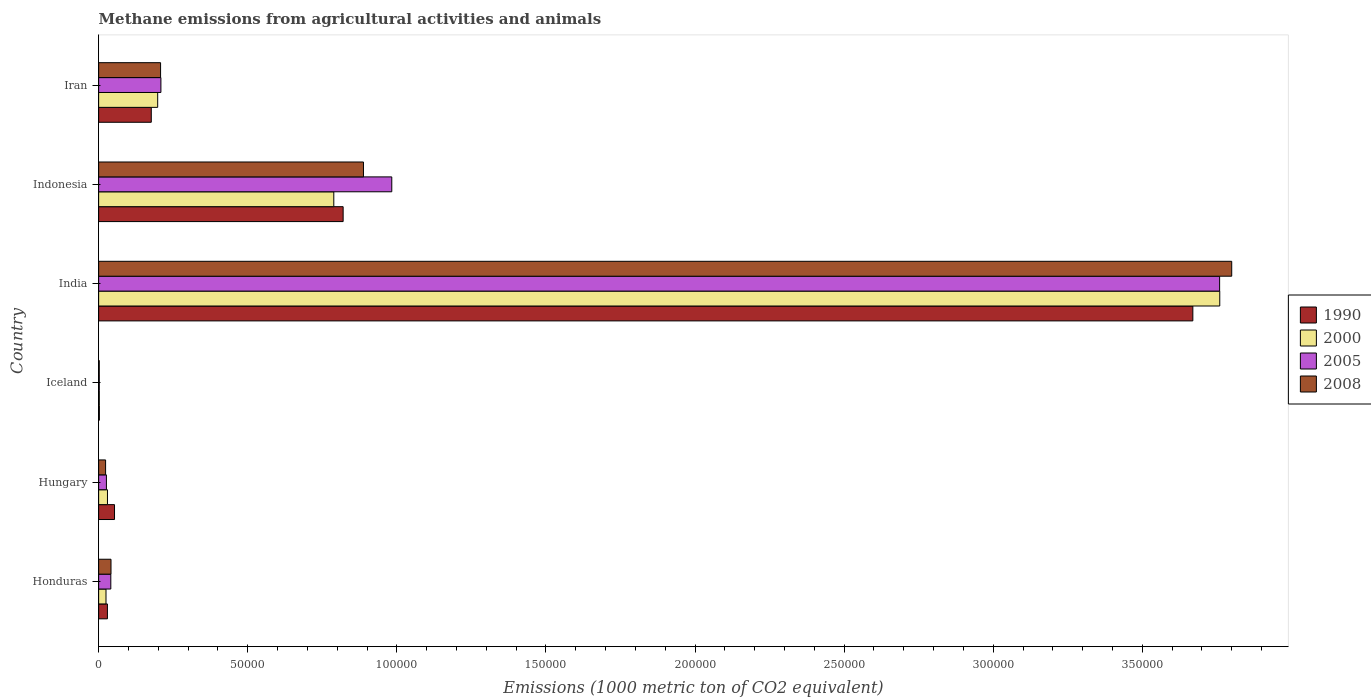How many groups of bars are there?
Provide a short and direct response. 6. How many bars are there on the 2nd tick from the top?
Make the answer very short. 4. How many bars are there on the 4th tick from the bottom?
Make the answer very short. 4. What is the label of the 2nd group of bars from the top?
Provide a short and direct response. Indonesia. In how many cases, is the number of bars for a given country not equal to the number of legend labels?
Give a very brief answer. 0. What is the amount of methane emitted in 2000 in Hungary?
Offer a very short reply. 2961.9. Across all countries, what is the maximum amount of methane emitted in 2008?
Offer a terse response. 3.80e+05. Across all countries, what is the minimum amount of methane emitted in 1990?
Give a very brief answer. 245.3. What is the total amount of methane emitted in 2008 in the graph?
Your answer should be compact. 4.96e+05. What is the difference between the amount of methane emitted in 2000 in Iceland and that in Indonesia?
Offer a terse response. -7.86e+04. What is the difference between the amount of methane emitted in 2008 in Honduras and the amount of methane emitted in 2000 in Iran?
Provide a succinct answer. -1.57e+04. What is the average amount of methane emitted in 2005 per country?
Your answer should be very brief. 8.37e+04. What is the difference between the amount of methane emitted in 2008 and amount of methane emitted in 1990 in Honduras?
Offer a terse response. 1202.8. What is the ratio of the amount of methane emitted in 1990 in Indonesia to that in Iran?
Your answer should be very brief. 4.64. Is the difference between the amount of methane emitted in 2008 in Honduras and India greater than the difference between the amount of methane emitted in 1990 in Honduras and India?
Your answer should be compact. No. What is the difference between the highest and the second highest amount of methane emitted in 2008?
Offer a terse response. 2.91e+05. What is the difference between the highest and the lowest amount of methane emitted in 2008?
Give a very brief answer. 3.80e+05. In how many countries, is the amount of methane emitted in 1990 greater than the average amount of methane emitted in 1990 taken over all countries?
Your response must be concise. 2. Is the sum of the amount of methane emitted in 1990 in Iceland and India greater than the maximum amount of methane emitted in 2000 across all countries?
Keep it short and to the point. No. What does the 4th bar from the top in Iceland represents?
Offer a terse response. 1990. What does the 1st bar from the bottom in Iran represents?
Ensure brevity in your answer.  1990. Is it the case that in every country, the sum of the amount of methane emitted in 2005 and amount of methane emitted in 2008 is greater than the amount of methane emitted in 1990?
Provide a succinct answer. No. How many countries are there in the graph?
Provide a short and direct response. 6. Are the values on the major ticks of X-axis written in scientific E-notation?
Give a very brief answer. No. How are the legend labels stacked?
Your answer should be compact. Vertical. What is the title of the graph?
Your response must be concise. Methane emissions from agricultural activities and animals. What is the label or title of the X-axis?
Offer a terse response. Emissions (1000 metric ton of CO2 equivalent). What is the Emissions (1000 metric ton of CO2 equivalent) in 1990 in Honduras?
Your answer should be very brief. 2946.5. What is the Emissions (1000 metric ton of CO2 equivalent) in 2000 in Honduras?
Give a very brief answer. 2470.9. What is the Emissions (1000 metric ton of CO2 equivalent) of 2005 in Honduras?
Your response must be concise. 4084.8. What is the Emissions (1000 metric ton of CO2 equivalent) in 2008 in Honduras?
Your response must be concise. 4149.3. What is the Emissions (1000 metric ton of CO2 equivalent) of 1990 in Hungary?
Offer a very short reply. 5327.6. What is the Emissions (1000 metric ton of CO2 equivalent) of 2000 in Hungary?
Your answer should be very brief. 2961.9. What is the Emissions (1000 metric ton of CO2 equivalent) in 2005 in Hungary?
Your answer should be very brief. 2613. What is the Emissions (1000 metric ton of CO2 equivalent) of 2008 in Hungary?
Ensure brevity in your answer.  2335.2. What is the Emissions (1000 metric ton of CO2 equivalent) of 1990 in Iceland?
Make the answer very short. 245.3. What is the Emissions (1000 metric ton of CO2 equivalent) in 2000 in Iceland?
Provide a short and direct response. 223.7. What is the Emissions (1000 metric ton of CO2 equivalent) of 2005 in Iceland?
Give a very brief answer. 214.9. What is the Emissions (1000 metric ton of CO2 equivalent) of 2008 in Iceland?
Your answer should be very brief. 209.2. What is the Emissions (1000 metric ton of CO2 equivalent) in 1990 in India?
Your answer should be compact. 3.67e+05. What is the Emissions (1000 metric ton of CO2 equivalent) in 2000 in India?
Ensure brevity in your answer.  3.76e+05. What is the Emissions (1000 metric ton of CO2 equivalent) in 2005 in India?
Make the answer very short. 3.76e+05. What is the Emissions (1000 metric ton of CO2 equivalent) in 2008 in India?
Keep it short and to the point. 3.80e+05. What is the Emissions (1000 metric ton of CO2 equivalent) in 1990 in Indonesia?
Give a very brief answer. 8.20e+04. What is the Emissions (1000 metric ton of CO2 equivalent) in 2000 in Indonesia?
Provide a short and direct response. 7.89e+04. What is the Emissions (1000 metric ton of CO2 equivalent) in 2005 in Indonesia?
Provide a succinct answer. 9.83e+04. What is the Emissions (1000 metric ton of CO2 equivalent) in 2008 in Indonesia?
Your answer should be very brief. 8.88e+04. What is the Emissions (1000 metric ton of CO2 equivalent) in 1990 in Iran?
Offer a terse response. 1.77e+04. What is the Emissions (1000 metric ton of CO2 equivalent) of 2000 in Iran?
Give a very brief answer. 1.98e+04. What is the Emissions (1000 metric ton of CO2 equivalent) in 2005 in Iran?
Offer a terse response. 2.09e+04. What is the Emissions (1000 metric ton of CO2 equivalent) of 2008 in Iran?
Your answer should be very brief. 2.08e+04. Across all countries, what is the maximum Emissions (1000 metric ton of CO2 equivalent) of 1990?
Provide a succinct answer. 3.67e+05. Across all countries, what is the maximum Emissions (1000 metric ton of CO2 equivalent) in 2000?
Provide a succinct answer. 3.76e+05. Across all countries, what is the maximum Emissions (1000 metric ton of CO2 equivalent) in 2005?
Provide a short and direct response. 3.76e+05. Across all countries, what is the maximum Emissions (1000 metric ton of CO2 equivalent) in 2008?
Give a very brief answer. 3.80e+05. Across all countries, what is the minimum Emissions (1000 metric ton of CO2 equivalent) in 1990?
Your answer should be very brief. 245.3. Across all countries, what is the minimum Emissions (1000 metric ton of CO2 equivalent) in 2000?
Provide a short and direct response. 223.7. Across all countries, what is the minimum Emissions (1000 metric ton of CO2 equivalent) in 2005?
Offer a very short reply. 214.9. Across all countries, what is the minimum Emissions (1000 metric ton of CO2 equivalent) of 2008?
Your response must be concise. 209.2. What is the total Emissions (1000 metric ton of CO2 equivalent) in 1990 in the graph?
Ensure brevity in your answer.  4.75e+05. What is the total Emissions (1000 metric ton of CO2 equivalent) of 2000 in the graph?
Ensure brevity in your answer.  4.80e+05. What is the total Emissions (1000 metric ton of CO2 equivalent) of 2005 in the graph?
Make the answer very short. 5.02e+05. What is the total Emissions (1000 metric ton of CO2 equivalent) in 2008 in the graph?
Make the answer very short. 4.96e+05. What is the difference between the Emissions (1000 metric ton of CO2 equivalent) of 1990 in Honduras and that in Hungary?
Provide a short and direct response. -2381.1. What is the difference between the Emissions (1000 metric ton of CO2 equivalent) in 2000 in Honduras and that in Hungary?
Your answer should be compact. -491. What is the difference between the Emissions (1000 metric ton of CO2 equivalent) of 2005 in Honduras and that in Hungary?
Ensure brevity in your answer.  1471.8. What is the difference between the Emissions (1000 metric ton of CO2 equivalent) in 2008 in Honduras and that in Hungary?
Offer a very short reply. 1814.1. What is the difference between the Emissions (1000 metric ton of CO2 equivalent) of 1990 in Honduras and that in Iceland?
Make the answer very short. 2701.2. What is the difference between the Emissions (1000 metric ton of CO2 equivalent) of 2000 in Honduras and that in Iceland?
Provide a succinct answer. 2247.2. What is the difference between the Emissions (1000 metric ton of CO2 equivalent) in 2005 in Honduras and that in Iceland?
Offer a terse response. 3869.9. What is the difference between the Emissions (1000 metric ton of CO2 equivalent) in 2008 in Honduras and that in Iceland?
Your answer should be very brief. 3940.1. What is the difference between the Emissions (1000 metric ton of CO2 equivalent) in 1990 in Honduras and that in India?
Offer a terse response. -3.64e+05. What is the difference between the Emissions (1000 metric ton of CO2 equivalent) in 2000 in Honduras and that in India?
Your answer should be compact. -3.74e+05. What is the difference between the Emissions (1000 metric ton of CO2 equivalent) in 2005 in Honduras and that in India?
Your answer should be very brief. -3.72e+05. What is the difference between the Emissions (1000 metric ton of CO2 equivalent) in 2008 in Honduras and that in India?
Your answer should be compact. -3.76e+05. What is the difference between the Emissions (1000 metric ton of CO2 equivalent) of 1990 in Honduras and that in Indonesia?
Offer a very short reply. -7.91e+04. What is the difference between the Emissions (1000 metric ton of CO2 equivalent) in 2000 in Honduras and that in Indonesia?
Your answer should be compact. -7.64e+04. What is the difference between the Emissions (1000 metric ton of CO2 equivalent) in 2005 in Honduras and that in Indonesia?
Your response must be concise. -9.42e+04. What is the difference between the Emissions (1000 metric ton of CO2 equivalent) of 2008 in Honduras and that in Indonesia?
Your answer should be compact. -8.47e+04. What is the difference between the Emissions (1000 metric ton of CO2 equivalent) of 1990 in Honduras and that in Iran?
Your answer should be very brief. -1.47e+04. What is the difference between the Emissions (1000 metric ton of CO2 equivalent) of 2000 in Honduras and that in Iran?
Your answer should be very brief. -1.73e+04. What is the difference between the Emissions (1000 metric ton of CO2 equivalent) of 2005 in Honduras and that in Iran?
Your answer should be very brief. -1.68e+04. What is the difference between the Emissions (1000 metric ton of CO2 equivalent) of 2008 in Honduras and that in Iran?
Provide a succinct answer. -1.66e+04. What is the difference between the Emissions (1000 metric ton of CO2 equivalent) in 1990 in Hungary and that in Iceland?
Ensure brevity in your answer.  5082.3. What is the difference between the Emissions (1000 metric ton of CO2 equivalent) in 2000 in Hungary and that in Iceland?
Make the answer very short. 2738.2. What is the difference between the Emissions (1000 metric ton of CO2 equivalent) of 2005 in Hungary and that in Iceland?
Offer a very short reply. 2398.1. What is the difference between the Emissions (1000 metric ton of CO2 equivalent) of 2008 in Hungary and that in Iceland?
Offer a terse response. 2126. What is the difference between the Emissions (1000 metric ton of CO2 equivalent) in 1990 in Hungary and that in India?
Your answer should be very brief. -3.62e+05. What is the difference between the Emissions (1000 metric ton of CO2 equivalent) of 2000 in Hungary and that in India?
Offer a very short reply. -3.73e+05. What is the difference between the Emissions (1000 metric ton of CO2 equivalent) of 2005 in Hungary and that in India?
Offer a very short reply. -3.73e+05. What is the difference between the Emissions (1000 metric ton of CO2 equivalent) in 2008 in Hungary and that in India?
Provide a succinct answer. -3.78e+05. What is the difference between the Emissions (1000 metric ton of CO2 equivalent) in 1990 in Hungary and that in Indonesia?
Your response must be concise. -7.67e+04. What is the difference between the Emissions (1000 metric ton of CO2 equivalent) in 2000 in Hungary and that in Indonesia?
Provide a short and direct response. -7.59e+04. What is the difference between the Emissions (1000 metric ton of CO2 equivalent) of 2005 in Hungary and that in Indonesia?
Make the answer very short. -9.57e+04. What is the difference between the Emissions (1000 metric ton of CO2 equivalent) of 2008 in Hungary and that in Indonesia?
Ensure brevity in your answer.  -8.65e+04. What is the difference between the Emissions (1000 metric ton of CO2 equivalent) of 1990 in Hungary and that in Iran?
Offer a very short reply. -1.23e+04. What is the difference between the Emissions (1000 metric ton of CO2 equivalent) of 2000 in Hungary and that in Iran?
Provide a short and direct response. -1.68e+04. What is the difference between the Emissions (1000 metric ton of CO2 equivalent) in 2005 in Hungary and that in Iran?
Your answer should be very brief. -1.83e+04. What is the difference between the Emissions (1000 metric ton of CO2 equivalent) in 2008 in Hungary and that in Iran?
Your response must be concise. -1.84e+04. What is the difference between the Emissions (1000 metric ton of CO2 equivalent) in 1990 in Iceland and that in India?
Ensure brevity in your answer.  -3.67e+05. What is the difference between the Emissions (1000 metric ton of CO2 equivalent) of 2000 in Iceland and that in India?
Your answer should be very brief. -3.76e+05. What is the difference between the Emissions (1000 metric ton of CO2 equivalent) of 2005 in Iceland and that in India?
Give a very brief answer. -3.76e+05. What is the difference between the Emissions (1000 metric ton of CO2 equivalent) of 2008 in Iceland and that in India?
Offer a very short reply. -3.80e+05. What is the difference between the Emissions (1000 metric ton of CO2 equivalent) in 1990 in Iceland and that in Indonesia?
Keep it short and to the point. -8.18e+04. What is the difference between the Emissions (1000 metric ton of CO2 equivalent) of 2000 in Iceland and that in Indonesia?
Ensure brevity in your answer.  -7.86e+04. What is the difference between the Emissions (1000 metric ton of CO2 equivalent) in 2005 in Iceland and that in Indonesia?
Give a very brief answer. -9.81e+04. What is the difference between the Emissions (1000 metric ton of CO2 equivalent) in 2008 in Iceland and that in Indonesia?
Your response must be concise. -8.86e+04. What is the difference between the Emissions (1000 metric ton of CO2 equivalent) in 1990 in Iceland and that in Iran?
Ensure brevity in your answer.  -1.74e+04. What is the difference between the Emissions (1000 metric ton of CO2 equivalent) of 2000 in Iceland and that in Iran?
Your answer should be compact. -1.96e+04. What is the difference between the Emissions (1000 metric ton of CO2 equivalent) in 2005 in Iceland and that in Iran?
Your answer should be compact. -2.07e+04. What is the difference between the Emissions (1000 metric ton of CO2 equivalent) in 2008 in Iceland and that in Iran?
Ensure brevity in your answer.  -2.06e+04. What is the difference between the Emissions (1000 metric ton of CO2 equivalent) of 1990 in India and that in Indonesia?
Give a very brief answer. 2.85e+05. What is the difference between the Emissions (1000 metric ton of CO2 equivalent) in 2000 in India and that in Indonesia?
Provide a succinct answer. 2.97e+05. What is the difference between the Emissions (1000 metric ton of CO2 equivalent) of 2005 in India and that in Indonesia?
Provide a succinct answer. 2.78e+05. What is the difference between the Emissions (1000 metric ton of CO2 equivalent) in 2008 in India and that in Indonesia?
Offer a very short reply. 2.91e+05. What is the difference between the Emissions (1000 metric ton of CO2 equivalent) of 1990 in India and that in Iran?
Ensure brevity in your answer.  3.49e+05. What is the difference between the Emissions (1000 metric ton of CO2 equivalent) in 2000 in India and that in Iran?
Your answer should be very brief. 3.56e+05. What is the difference between the Emissions (1000 metric ton of CO2 equivalent) of 2005 in India and that in Iran?
Keep it short and to the point. 3.55e+05. What is the difference between the Emissions (1000 metric ton of CO2 equivalent) in 2008 in India and that in Iran?
Offer a very short reply. 3.59e+05. What is the difference between the Emissions (1000 metric ton of CO2 equivalent) of 1990 in Indonesia and that in Iran?
Your answer should be very brief. 6.43e+04. What is the difference between the Emissions (1000 metric ton of CO2 equivalent) in 2000 in Indonesia and that in Iran?
Give a very brief answer. 5.91e+04. What is the difference between the Emissions (1000 metric ton of CO2 equivalent) in 2005 in Indonesia and that in Iran?
Give a very brief answer. 7.74e+04. What is the difference between the Emissions (1000 metric ton of CO2 equivalent) in 2008 in Indonesia and that in Iran?
Make the answer very short. 6.80e+04. What is the difference between the Emissions (1000 metric ton of CO2 equivalent) of 1990 in Honduras and the Emissions (1000 metric ton of CO2 equivalent) of 2000 in Hungary?
Provide a succinct answer. -15.4. What is the difference between the Emissions (1000 metric ton of CO2 equivalent) in 1990 in Honduras and the Emissions (1000 metric ton of CO2 equivalent) in 2005 in Hungary?
Give a very brief answer. 333.5. What is the difference between the Emissions (1000 metric ton of CO2 equivalent) in 1990 in Honduras and the Emissions (1000 metric ton of CO2 equivalent) in 2008 in Hungary?
Offer a terse response. 611.3. What is the difference between the Emissions (1000 metric ton of CO2 equivalent) in 2000 in Honduras and the Emissions (1000 metric ton of CO2 equivalent) in 2005 in Hungary?
Give a very brief answer. -142.1. What is the difference between the Emissions (1000 metric ton of CO2 equivalent) of 2000 in Honduras and the Emissions (1000 metric ton of CO2 equivalent) of 2008 in Hungary?
Provide a short and direct response. 135.7. What is the difference between the Emissions (1000 metric ton of CO2 equivalent) of 2005 in Honduras and the Emissions (1000 metric ton of CO2 equivalent) of 2008 in Hungary?
Provide a short and direct response. 1749.6. What is the difference between the Emissions (1000 metric ton of CO2 equivalent) of 1990 in Honduras and the Emissions (1000 metric ton of CO2 equivalent) of 2000 in Iceland?
Offer a very short reply. 2722.8. What is the difference between the Emissions (1000 metric ton of CO2 equivalent) of 1990 in Honduras and the Emissions (1000 metric ton of CO2 equivalent) of 2005 in Iceland?
Provide a short and direct response. 2731.6. What is the difference between the Emissions (1000 metric ton of CO2 equivalent) of 1990 in Honduras and the Emissions (1000 metric ton of CO2 equivalent) of 2008 in Iceland?
Offer a terse response. 2737.3. What is the difference between the Emissions (1000 metric ton of CO2 equivalent) of 2000 in Honduras and the Emissions (1000 metric ton of CO2 equivalent) of 2005 in Iceland?
Keep it short and to the point. 2256. What is the difference between the Emissions (1000 metric ton of CO2 equivalent) of 2000 in Honduras and the Emissions (1000 metric ton of CO2 equivalent) of 2008 in Iceland?
Make the answer very short. 2261.7. What is the difference between the Emissions (1000 metric ton of CO2 equivalent) in 2005 in Honduras and the Emissions (1000 metric ton of CO2 equivalent) in 2008 in Iceland?
Your answer should be very brief. 3875.6. What is the difference between the Emissions (1000 metric ton of CO2 equivalent) in 1990 in Honduras and the Emissions (1000 metric ton of CO2 equivalent) in 2000 in India?
Your response must be concise. -3.73e+05. What is the difference between the Emissions (1000 metric ton of CO2 equivalent) in 1990 in Honduras and the Emissions (1000 metric ton of CO2 equivalent) in 2005 in India?
Offer a very short reply. -3.73e+05. What is the difference between the Emissions (1000 metric ton of CO2 equivalent) in 1990 in Honduras and the Emissions (1000 metric ton of CO2 equivalent) in 2008 in India?
Provide a succinct answer. -3.77e+05. What is the difference between the Emissions (1000 metric ton of CO2 equivalent) of 2000 in Honduras and the Emissions (1000 metric ton of CO2 equivalent) of 2005 in India?
Give a very brief answer. -3.73e+05. What is the difference between the Emissions (1000 metric ton of CO2 equivalent) in 2000 in Honduras and the Emissions (1000 metric ton of CO2 equivalent) in 2008 in India?
Your response must be concise. -3.78e+05. What is the difference between the Emissions (1000 metric ton of CO2 equivalent) in 2005 in Honduras and the Emissions (1000 metric ton of CO2 equivalent) in 2008 in India?
Give a very brief answer. -3.76e+05. What is the difference between the Emissions (1000 metric ton of CO2 equivalent) of 1990 in Honduras and the Emissions (1000 metric ton of CO2 equivalent) of 2000 in Indonesia?
Your answer should be compact. -7.59e+04. What is the difference between the Emissions (1000 metric ton of CO2 equivalent) in 1990 in Honduras and the Emissions (1000 metric ton of CO2 equivalent) in 2005 in Indonesia?
Offer a terse response. -9.54e+04. What is the difference between the Emissions (1000 metric ton of CO2 equivalent) in 1990 in Honduras and the Emissions (1000 metric ton of CO2 equivalent) in 2008 in Indonesia?
Provide a succinct answer. -8.59e+04. What is the difference between the Emissions (1000 metric ton of CO2 equivalent) in 2000 in Honduras and the Emissions (1000 metric ton of CO2 equivalent) in 2005 in Indonesia?
Make the answer very short. -9.58e+04. What is the difference between the Emissions (1000 metric ton of CO2 equivalent) of 2000 in Honduras and the Emissions (1000 metric ton of CO2 equivalent) of 2008 in Indonesia?
Keep it short and to the point. -8.63e+04. What is the difference between the Emissions (1000 metric ton of CO2 equivalent) in 2005 in Honduras and the Emissions (1000 metric ton of CO2 equivalent) in 2008 in Indonesia?
Provide a succinct answer. -8.47e+04. What is the difference between the Emissions (1000 metric ton of CO2 equivalent) in 1990 in Honduras and the Emissions (1000 metric ton of CO2 equivalent) in 2000 in Iran?
Your answer should be very brief. -1.69e+04. What is the difference between the Emissions (1000 metric ton of CO2 equivalent) in 1990 in Honduras and the Emissions (1000 metric ton of CO2 equivalent) in 2005 in Iran?
Keep it short and to the point. -1.79e+04. What is the difference between the Emissions (1000 metric ton of CO2 equivalent) in 1990 in Honduras and the Emissions (1000 metric ton of CO2 equivalent) in 2008 in Iran?
Keep it short and to the point. -1.78e+04. What is the difference between the Emissions (1000 metric ton of CO2 equivalent) of 2000 in Honduras and the Emissions (1000 metric ton of CO2 equivalent) of 2005 in Iran?
Offer a very short reply. -1.84e+04. What is the difference between the Emissions (1000 metric ton of CO2 equivalent) in 2000 in Honduras and the Emissions (1000 metric ton of CO2 equivalent) in 2008 in Iran?
Make the answer very short. -1.83e+04. What is the difference between the Emissions (1000 metric ton of CO2 equivalent) of 2005 in Honduras and the Emissions (1000 metric ton of CO2 equivalent) of 2008 in Iran?
Your response must be concise. -1.67e+04. What is the difference between the Emissions (1000 metric ton of CO2 equivalent) in 1990 in Hungary and the Emissions (1000 metric ton of CO2 equivalent) in 2000 in Iceland?
Offer a very short reply. 5103.9. What is the difference between the Emissions (1000 metric ton of CO2 equivalent) in 1990 in Hungary and the Emissions (1000 metric ton of CO2 equivalent) in 2005 in Iceland?
Make the answer very short. 5112.7. What is the difference between the Emissions (1000 metric ton of CO2 equivalent) in 1990 in Hungary and the Emissions (1000 metric ton of CO2 equivalent) in 2008 in Iceland?
Keep it short and to the point. 5118.4. What is the difference between the Emissions (1000 metric ton of CO2 equivalent) in 2000 in Hungary and the Emissions (1000 metric ton of CO2 equivalent) in 2005 in Iceland?
Give a very brief answer. 2747. What is the difference between the Emissions (1000 metric ton of CO2 equivalent) in 2000 in Hungary and the Emissions (1000 metric ton of CO2 equivalent) in 2008 in Iceland?
Your answer should be compact. 2752.7. What is the difference between the Emissions (1000 metric ton of CO2 equivalent) in 2005 in Hungary and the Emissions (1000 metric ton of CO2 equivalent) in 2008 in Iceland?
Your answer should be very brief. 2403.8. What is the difference between the Emissions (1000 metric ton of CO2 equivalent) in 1990 in Hungary and the Emissions (1000 metric ton of CO2 equivalent) in 2000 in India?
Give a very brief answer. -3.71e+05. What is the difference between the Emissions (1000 metric ton of CO2 equivalent) of 1990 in Hungary and the Emissions (1000 metric ton of CO2 equivalent) of 2005 in India?
Offer a very short reply. -3.71e+05. What is the difference between the Emissions (1000 metric ton of CO2 equivalent) of 1990 in Hungary and the Emissions (1000 metric ton of CO2 equivalent) of 2008 in India?
Ensure brevity in your answer.  -3.75e+05. What is the difference between the Emissions (1000 metric ton of CO2 equivalent) of 2000 in Hungary and the Emissions (1000 metric ton of CO2 equivalent) of 2005 in India?
Ensure brevity in your answer.  -3.73e+05. What is the difference between the Emissions (1000 metric ton of CO2 equivalent) of 2000 in Hungary and the Emissions (1000 metric ton of CO2 equivalent) of 2008 in India?
Make the answer very short. -3.77e+05. What is the difference between the Emissions (1000 metric ton of CO2 equivalent) of 2005 in Hungary and the Emissions (1000 metric ton of CO2 equivalent) of 2008 in India?
Keep it short and to the point. -3.77e+05. What is the difference between the Emissions (1000 metric ton of CO2 equivalent) in 1990 in Hungary and the Emissions (1000 metric ton of CO2 equivalent) in 2000 in Indonesia?
Keep it short and to the point. -7.35e+04. What is the difference between the Emissions (1000 metric ton of CO2 equivalent) in 1990 in Hungary and the Emissions (1000 metric ton of CO2 equivalent) in 2005 in Indonesia?
Offer a very short reply. -9.30e+04. What is the difference between the Emissions (1000 metric ton of CO2 equivalent) in 1990 in Hungary and the Emissions (1000 metric ton of CO2 equivalent) in 2008 in Indonesia?
Give a very brief answer. -8.35e+04. What is the difference between the Emissions (1000 metric ton of CO2 equivalent) in 2000 in Hungary and the Emissions (1000 metric ton of CO2 equivalent) in 2005 in Indonesia?
Offer a terse response. -9.53e+04. What is the difference between the Emissions (1000 metric ton of CO2 equivalent) in 2000 in Hungary and the Emissions (1000 metric ton of CO2 equivalent) in 2008 in Indonesia?
Your answer should be very brief. -8.59e+04. What is the difference between the Emissions (1000 metric ton of CO2 equivalent) in 2005 in Hungary and the Emissions (1000 metric ton of CO2 equivalent) in 2008 in Indonesia?
Your answer should be very brief. -8.62e+04. What is the difference between the Emissions (1000 metric ton of CO2 equivalent) of 1990 in Hungary and the Emissions (1000 metric ton of CO2 equivalent) of 2000 in Iran?
Offer a very short reply. -1.45e+04. What is the difference between the Emissions (1000 metric ton of CO2 equivalent) of 1990 in Hungary and the Emissions (1000 metric ton of CO2 equivalent) of 2005 in Iran?
Your answer should be compact. -1.56e+04. What is the difference between the Emissions (1000 metric ton of CO2 equivalent) in 1990 in Hungary and the Emissions (1000 metric ton of CO2 equivalent) in 2008 in Iran?
Your answer should be very brief. -1.54e+04. What is the difference between the Emissions (1000 metric ton of CO2 equivalent) of 2000 in Hungary and the Emissions (1000 metric ton of CO2 equivalent) of 2005 in Iran?
Ensure brevity in your answer.  -1.79e+04. What is the difference between the Emissions (1000 metric ton of CO2 equivalent) in 2000 in Hungary and the Emissions (1000 metric ton of CO2 equivalent) in 2008 in Iran?
Your answer should be compact. -1.78e+04. What is the difference between the Emissions (1000 metric ton of CO2 equivalent) of 2005 in Hungary and the Emissions (1000 metric ton of CO2 equivalent) of 2008 in Iran?
Make the answer very short. -1.82e+04. What is the difference between the Emissions (1000 metric ton of CO2 equivalent) of 1990 in Iceland and the Emissions (1000 metric ton of CO2 equivalent) of 2000 in India?
Your answer should be compact. -3.76e+05. What is the difference between the Emissions (1000 metric ton of CO2 equivalent) of 1990 in Iceland and the Emissions (1000 metric ton of CO2 equivalent) of 2005 in India?
Your answer should be very brief. -3.76e+05. What is the difference between the Emissions (1000 metric ton of CO2 equivalent) of 1990 in Iceland and the Emissions (1000 metric ton of CO2 equivalent) of 2008 in India?
Offer a very short reply. -3.80e+05. What is the difference between the Emissions (1000 metric ton of CO2 equivalent) in 2000 in Iceland and the Emissions (1000 metric ton of CO2 equivalent) in 2005 in India?
Make the answer very short. -3.76e+05. What is the difference between the Emissions (1000 metric ton of CO2 equivalent) of 2000 in Iceland and the Emissions (1000 metric ton of CO2 equivalent) of 2008 in India?
Your answer should be very brief. -3.80e+05. What is the difference between the Emissions (1000 metric ton of CO2 equivalent) of 2005 in Iceland and the Emissions (1000 metric ton of CO2 equivalent) of 2008 in India?
Ensure brevity in your answer.  -3.80e+05. What is the difference between the Emissions (1000 metric ton of CO2 equivalent) in 1990 in Iceland and the Emissions (1000 metric ton of CO2 equivalent) in 2000 in Indonesia?
Offer a very short reply. -7.86e+04. What is the difference between the Emissions (1000 metric ton of CO2 equivalent) in 1990 in Iceland and the Emissions (1000 metric ton of CO2 equivalent) in 2005 in Indonesia?
Offer a terse response. -9.81e+04. What is the difference between the Emissions (1000 metric ton of CO2 equivalent) in 1990 in Iceland and the Emissions (1000 metric ton of CO2 equivalent) in 2008 in Indonesia?
Offer a very short reply. -8.86e+04. What is the difference between the Emissions (1000 metric ton of CO2 equivalent) in 2000 in Iceland and the Emissions (1000 metric ton of CO2 equivalent) in 2005 in Indonesia?
Your answer should be compact. -9.81e+04. What is the difference between the Emissions (1000 metric ton of CO2 equivalent) of 2000 in Iceland and the Emissions (1000 metric ton of CO2 equivalent) of 2008 in Indonesia?
Give a very brief answer. -8.86e+04. What is the difference between the Emissions (1000 metric ton of CO2 equivalent) of 2005 in Iceland and the Emissions (1000 metric ton of CO2 equivalent) of 2008 in Indonesia?
Your response must be concise. -8.86e+04. What is the difference between the Emissions (1000 metric ton of CO2 equivalent) of 1990 in Iceland and the Emissions (1000 metric ton of CO2 equivalent) of 2000 in Iran?
Offer a very short reply. -1.96e+04. What is the difference between the Emissions (1000 metric ton of CO2 equivalent) of 1990 in Iceland and the Emissions (1000 metric ton of CO2 equivalent) of 2005 in Iran?
Your answer should be very brief. -2.06e+04. What is the difference between the Emissions (1000 metric ton of CO2 equivalent) of 1990 in Iceland and the Emissions (1000 metric ton of CO2 equivalent) of 2008 in Iran?
Ensure brevity in your answer.  -2.05e+04. What is the difference between the Emissions (1000 metric ton of CO2 equivalent) of 2000 in Iceland and the Emissions (1000 metric ton of CO2 equivalent) of 2005 in Iran?
Offer a very short reply. -2.07e+04. What is the difference between the Emissions (1000 metric ton of CO2 equivalent) in 2000 in Iceland and the Emissions (1000 metric ton of CO2 equivalent) in 2008 in Iran?
Your answer should be very brief. -2.06e+04. What is the difference between the Emissions (1000 metric ton of CO2 equivalent) of 2005 in Iceland and the Emissions (1000 metric ton of CO2 equivalent) of 2008 in Iran?
Give a very brief answer. -2.06e+04. What is the difference between the Emissions (1000 metric ton of CO2 equivalent) in 1990 in India and the Emissions (1000 metric ton of CO2 equivalent) in 2000 in Indonesia?
Ensure brevity in your answer.  2.88e+05. What is the difference between the Emissions (1000 metric ton of CO2 equivalent) in 1990 in India and the Emissions (1000 metric ton of CO2 equivalent) in 2005 in Indonesia?
Provide a succinct answer. 2.69e+05. What is the difference between the Emissions (1000 metric ton of CO2 equivalent) of 1990 in India and the Emissions (1000 metric ton of CO2 equivalent) of 2008 in Indonesia?
Offer a terse response. 2.78e+05. What is the difference between the Emissions (1000 metric ton of CO2 equivalent) in 2000 in India and the Emissions (1000 metric ton of CO2 equivalent) in 2005 in Indonesia?
Offer a terse response. 2.78e+05. What is the difference between the Emissions (1000 metric ton of CO2 equivalent) of 2000 in India and the Emissions (1000 metric ton of CO2 equivalent) of 2008 in Indonesia?
Give a very brief answer. 2.87e+05. What is the difference between the Emissions (1000 metric ton of CO2 equivalent) in 2005 in India and the Emissions (1000 metric ton of CO2 equivalent) in 2008 in Indonesia?
Provide a succinct answer. 2.87e+05. What is the difference between the Emissions (1000 metric ton of CO2 equivalent) of 1990 in India and the Emissions (1000 metric ton of CO2 equivalent) of 2000 in Iran?
Your answer should be compact. 3.47e+05. What is the difference between the Emissions (1000 metric ton of CO2 equivalent) of 1990 in India and the Emissions (1000 metric ton of CO2 equivalent) of 2005 in Iran?
Make the answer very short. 3.46e+05. What is the difference between the Emissions (1000 metric ton of CO2 equivalent) in 1990 in India and the Emissions (1000 metric ton of CO2 equivalent) in 2008 in Iran?
Your response must be concise. 3.46e+05. What is the difference between the Emissions (1000 metric ton of CO2 equivalent) in 2000 in India and the Emissions (1000 metric ton of CO2 equivalent) in 2005 in Iran?
Offer a terse response. 3.55e+05. What is the difference between the Emissions (1000 metric ton of CO2 equivalent) in 2000 in India and the Emissions (1000 metric ton of CO2 equivalent) in 2008 in Iran?
Offer a very short reply. 3.55e+05. What is the difference between the Emissions (1000 metric ton of CO2 equivalent) in 2005 in India and the Emissions (1000 metric ton of CO2 equivalent) in 2008 in Iran?
Your answer should be compact. 3.55e+05. What is the difference between the Emissions (1000 metric ton of CO2 equivalent) in 1990 in Indonesia and the Emissions (1000 metric ton of CO2 equivalent) in 2000 in Iran?
Give a very brief answer. 6.22e+04. What is the difference between the Emissions (1000 metric ton of CO2 equivalent) of 1990 in Indonesia and the Emissions (1000 metric ton of CO2 equivalent) of 2005 in Iran?
Offer a very short reply. 6.11e+04. What is the difference between the Emissions (1000 metric ton of CO2 equivalent) of 1990 in Indonesia and the Emissions (1000 metric ton of CO2 equivalent) of 2008 in Iran?
Offer a very short reply. 6.12e+04. What is the difference between the Emissions (1000 metric ton of CO2 equivalent) in 2000 in Indonesia and the Emissions (1000 metric ton of CO2 equivalent) in 2005 in Iran?
Your response must be concise. 5.80e+04. What is the difference between the Emissions (1000 metric ton of CO2 equivalent) of 2000 in Indonesia and the Emissions (1000 metric ton of CO2 equivalent) of 2008 in Iran?
Offer a terse response. 5.81e+04. What is the difference between the Emissions (1000 metric ton of CO2 equivalent) of 2005 in Indonesia and the Emissions (1000 metric ton of CO2 equivalent) of 2008 in Iran?
Ensure brevity in your answer.  7.75e+04. What is the average Emissions (1000 metric ton of CO2 equivalent) in 1990 per country?
Provide a succinct answer. 7.92e+04. What is the average Emissions (1000 metric ton of CO2 equivalent) in 2000 per country?
Keep it short and to the point. 8.00e+04. What is the average Emissions (1000 metric ton of CO2 equivalent) of 2005 per country?
Provide a short and direct response. 8.37e+04. What is the average Emissions (1000 metric ton of CO2 equivalent) of 2008 per country?
Provide a short and direct response. 8.27e+04. What is the difference between the Emissions (1000 metric ton of CO2 equivalent) in 1990 and Emissions (1000 metric ton of CO2 equivalent) in 2000 in Honduras?
Ensure brevity in your answer.  475.6. What is the difference between the Emissions (1000 metric ton of CO2 equivalent) in 1990 and Emissions (1000 metric ton of CO2 equivalent) in 2005 in Honduras?
Offer a very short reply. -1138.3. What is the difference between the Emissions (1000 metric ton of CO2 equivalent) of 1990 and Emissions (1000 metric ton of CO2 equivalent) of 2008 in Honduras?
Your answer should be compact. -1202.8. What is the difference between the Emissions (1000 metric ton of CO2 equivalent) in 2000 and Emissions (1000 metric ton of CO2 equivalent) in 2005 in Honduras?
Your response must be concise. -1613.9. What is the difference between the Emissions (1000 metric ton of CO2 equivalent) of 2000 and Emissions (1000 metric ton of CO2 equivalent) of 2008 in Honduras?
Ensure brevity in your answer.  -1678.4. What is the difference between the Emissions (1000 metric ton of CO2 equivalent) of 2005 and Emissions (1000 metric ton of CO2 equivalent) of 2008 in Honduras?
Your answer should be very brief. -64.5. What is the difference between the Emissions (1000 metric ton of CO2 equivalent) in 1990 and Emissions (1000 metric ton of CO2 equivalent) in 2000 in Hungary?
Your answer should be compact. 2365.7. What is the difference between the Emissions (1000 metric ton of CO2 equivalent) of 1990 and Emissions (1000 metric ton of CO2 equivalent) of 2005 in Hungary?
Your response must be concise. 2714.6. What is the difference between the Emissions (1000 metric ton of CO2 equivalent) of 1990 and Emissions (1000 metric ton of CO2 equivalent) of 2008 in Hungary?
Your response must be concise. 2992.4. What is the difference between the Emissions (1000 metric ton of CO2 equivalent) in 2000 and Emissions (1000 metric ton of CO2 equivalent) in 2005 in Hungary?
Make the answer very short. 348.9. What is the difference between the Emissions (1000 metric ton of CO2 equivalent) of 2000 and Emissions (1000 metric ton of CO2 equivalent) of 2008 in Hungary?
Offer a very short reply. 626.7. What is the difference between the Emissions (1000 metric ton of CO2 equivalent) in 2005 and Emissions (1000 metric ton of CO2 equivalent) in 2008 in Hungary?
Keep it short and to the point. 277.8. What is the difference between the Emissions (1000 metric ton of CO2 equivalent) of 1990 and Emissions (1000 metric ton of CO2 equivalent) of 2000 in Iceland?
Provide a short and direct response. 21.6. What is the difference between the Emissions (1000 metric ton of CO2 equivalent) of 1990 and Emissions (1000 metric ton of CO2 equivalent) of 2005 in Iceland?
Your answer should be very brief. 30.4. What is the difference between the Emissions (1000 metric ton of CO2 equivalent) of 1990 and Emissions (1000 metric ton of CO2 equivalent) of 2008 in Iceland?
Offer a terse response. 36.1. What is the difference between the Emissions (1000 metric ton of CO2 equivalent) in 1990 and Emissions (1000 metric ton of CO2 equivalent) in 2000 in India?
Your answer should be very brief. -9029.4. What is the difference between the Emissions (1000 metric ton of CO2 equivalent) in 1990 and Emissions (1000 metric ton of CO2 equivalent) in 2005 in India?
Your answer should be very brief. -8983.7. What is the difference between the Emissions (1000 metric ton of CO2 equivalent) in 1990 and Emissions (1000 metric ton of CO2 equivalent) in 2008 in India?
Your answer should be very brief. -1.30e+04. What is the difference between the Emissions (1000 metric ton of CO2 equivalent) in 2000 and Emissions (1000 metric ton of CO2 equivalent) in 2005 in India?
Offer a very short reply. 45.7. What is the difference between the Emissions (1000 metric ton of CO2 equivalent) of 2000 and Emissions (1000 metric ton of CO2 equivalent) of 2008 in India?
Offer a very short reply. -4005.8. What is the difference between the Emissions (1000 metric ton of CO2 equivalent) of 2005 and Emissions (1000 metric ton of CO2 equivalent) of 2008 in India?
Ensure brevity in your answer.  -4051.5. What is the difference between the Emissions (1000 metric ton of CO2 equivalent) of 1990 and Emissions (1000 metric ton of CO2 equivalent) of 2000 in Indonesia?
Offer a very short reply. 3136.2. What is the difference between the Emissions (1000 metric ton of CO2 equivalent) in 1990 and Emissions (1000 metric ton of CO2 equivalent) in 2005 in Indonesia?
Your answer should be very brief. -1.63e+04. What is the difference between the Emissions (1000 metric ton of CO2 equivalent) of 1990 and Emissions (1000 metric ton of CO2 equivalent) of 2008 in Indonesia?
Make the answer very short. -6814.3. What is the difference between the Emissions (1000 metric ton of CO2 equivalent) of 2000 and Emissions (1000 metric ton of CO2 equivalent) of 2005 in Indonesia?
Your response must be concise. -1.94e+04. What is the difference between the Emissions (1000 metric ton of CO2 equivalent) of 2000 and Emissions (1000 metric ton of CO2 equivalent) of 2008 in Indonesia?
Offer a very short reply. -9950.5. What is the difference between the Emissions (1000 metric ton of CO2 equivalent) of 2005 and Emissions (1000 metric ton of CO2 equivalent) of 2008 in Indonesia?
Make the answer very short. 9496.1. What is the difference between the Emissions (1000 metric ton of CO2 equivalent) of 1990 and Emissions (1000 metric ton of CO2 equivalent) of 2000 in Iran?
Make the answer very short. -2149.4. What is the difference between the Emissions (1000 metric ton of CO2 equivalent) in 1990 and Emissions (1000 metric ton of CO2 equivalent) in 2005 in Iran?
Offer a terse response. -3226.3. What is the difference between the Emissions (1000 metric ton of CO2 equivalent) in 1990 and Emissions (1000 metric ton of CO2 equivalent) in 2008 in Iran?
Your answer should be compact. -3119.6. What is the difference between the Emissions (1000 metric ton of CO2 equivalent) in 2000 and Emissions (1000 metric ton of CO2 equivalent) in 2005 in Iran?
Give a very brief answer. -1076.9. What is the difference between the Emissions (1000 metric ton of CO2 equivalent) in 2000 and Emissions (1000 metric ton of CO2 equivalent) in 2008 in Iran?
Ensure brevity in your answer.  -970.2. What is the difference between the Emissions (1000 metric ton of CO2 equivalent) in 2005 and Emissions (1000 metric ton of CO2 equivalent) in 2008 in Iran?
Keep it short and to the point. 106.7. What is the ratio of the Emissions (1000 metric ton of CO2 equivalent) in 1990 in Honduras to that in Hungary?
Provide a short and direct response. 0.55. What is the ratio of the Emissions (1000 metric ton of CO2 equivalent) of 2000 in Honduras to that in Hungary?
Your response must be concise. 0.83. What is the ratio of the Emissions (1000 metric ton of CO2 equivalent) in 2005 in Honduras to that in Hungary?
Your answer should be compact. 1.56. What is the ratio of the Emissions (1000 metric ton of CO2 equivalent) of 2008 in Honduras to that in Hungary?
Offer a very short reply. 1.78. What is the ratio of the Emissions (1000 metric ton of CO2 equivalent) in 1990 in Honduras to that in Iceland?
Your answer should be very brief. 12.01. What is the ratio of the Emissions (1000 metric ton of CO2 equivalent) of 2000 in Honduras to that in Iceland?
Provide a succinct answer. 11.05. What is the ratio of the Emissions (1000 metric ton of CO2 equivalent) in 2005 in Honduras to that in Iceland?
Provide a succinct answer. 19.01. What is the ratio of the Emissions (1000 metric ton of CO2 equivalent) in 2008 in Honduras to that in Iceland?
Your answer should be very brief. 19.83. What is the ratio of the Emissions (1000 metric ton of CO2 equivalent) of 1990 in Honduras to that in India?
Your response must be concise. 0.01. What is the ratio of the Emissions (1000 metric ton of CO2 equivalent) in 2000 in Honduras to that in India?
Offer a terse response. 0.01. What is the ratio of the Emissions (1000 metric ton of CO2 equivalent) of 2005 in Honduras to that in India?
Provide a succinct answer. 0.01. What is the ratio of the Emissions (1000 metric ton of CO2 equivalent) of 2008 in Honduras to that in India?
Offer a very short reply. 0.01. What is the ratio of the Emissions (1000 metric ton of CO2 equivalent) of 1990 in Honduras to that in Indonesia?
Make the answer very short. 0.04. What is the ratio of the Emissions (1000 metric ton of CO2 equivalent) in 2000 in Honduras to that in Indonesia?
Your answer should be compact. 0.03. What is the ratio of the Emissions (1000 metric ton of CO2 equivalent) of 2005 in Honduras to that in Indonesia?
Offer a terse response. 0.04. What is the ratio of the Emissions (1000 metric ton of CO2 equivalent) in 2008 in Honduras to that in Indonesia?
Give a very brief answer. 0.05. What is the ratio of the Emissions (1000 metric ton of CO2 equivalent) in 1990 in Honduras to that in Iran?
Give a very brief answer. 0.17. What is the ratio of the Emissions (1000 metric ton of CO2 equivalent) of 2000 in Honduras to that in Iran?
Provide a short and direct response. 0.12. What is the ratio of the Emissions (1000 metric ton of CO2 equivalent) in 2005 in Honduras to that in Iran?
Offer a terse response. 0.2. What is the ratio of the Emissions (1000 metric ton of CO2 equivalent) of 2008 in Honduras to that in Iran?
Offer a terse response. 0.2. What is the ratio of the Emissions (1000 metric ton of CO2 equivalent) in 1990 in Hungary to that in Iceland?
Keep it short and to the point. 21.72. What is the ratio of the Emissions (1000 metric ton of CO2 equivalent) of 2000 in Hungary to that in Iceland?
Provide a succinct answer. 13.24. What is the ratio of the Emissions (1000 metric ton of CO2 equivalent) of 2005 in Hungary to that in Iceland?
Provide a succinct answer. 12.16. What is the ratio of the Emissions (1000 metric ton of CO2 equivalent) of 2008 in Hungary to that in Iceland?
Provide a short and direct response. 11.16. What is the ratio of the Emissions (1000 metric ton of CO2 equivalent) of 1990 in Hungary to that in India?
Offer a very short reply. 0.01. What is the ratio of the Emissions (1000 metric ton of CO2 equivalent) of 2000 in Hungary to that in India?
Provide a succinct answer. 0.01. What is the ratio of the Emissions (1000 metric ton of CO2 equivalent) in 2005 in Hungary to that in India?
Provide a short and direct response. 0.01. What is the ratio of the Emissions (1000 metric ton of CO2 equivalent) in 2008 in Hungary to that in India?
Your response must be concise. 0.01. What is the ratio of the Emissions (1000 metric ton of CO2 equivalent) in 1990 in Hungary to that in Indonesia?
Provide a succinct answer. 0.07. What is the ratio of the Emissions (1000 metric ton of CO2 equivalent) of 2000 in Hungary to that in Indonesia?
Your answer should be very brief. 0.04. What is the ratio of the Emissions (1000 metric ton of CO2 equivalent) of 2005 in Hungary to that in Indonesia?
Offer a terse response. 0.03. What is the ratio of the Emissions (1000 metric ton of CO2 equivalent) of 2008 in Hungary to that in Indonesia?
Provide a short and direct response. 0.03. What is the ratio of the Emissions (1000 metric ton of CO2 equivalent) in 1990 in Hungary to that in Iran?
Offer a terse response. 0.3. What is the ratio of the Emissions (1000 metric ton of CO2 equivalent) in 2000 in Hungary to that in Iran?
Keep it short and to the point. 0.15. What is the ratio of the Emissions (1000 metric ton of CO2 equivalent) in 2005 in Hungary to that in Iran?
Provide a succinct answer. 0.13. What is the ratio of the Emissions (1000 metric ton of CO2 equivalent) in 2008 in Hungary to that in Iran?
Provide a short and direct response. 0.11. What is the ratio of the Emissions (1000 metric ton of CO2 equivalent) in 1990 in Iceland to that in India?
Give a very brief answer. 0. What is the ratio of the Emissions (1000 metric ton of CO2 equivalent) in 2000 in Iceland to that in India?
Your response must be concise. 0. What is the ratio of the Emissions (1000 metric ton of CO2 equivalent) of 2005 in Iceland to that in India?
Make the answer very short. 0. What is the ratio of the Emissions (1000 metric ton of CO2 equivalent) in 2008 in Iceland to that in India?
Your answer should be very brief. 0. What is the ratio of the Emissions (1000 metric ton of CO2 equivalent) in 1990 in Iceland to that in Indonesia?
Offer a terse response. 0. What is the ratio of the Emissions (1000 metric ton of CO2 equivalent) in 2000 in Iceland to that in Indonesia?
Provide a short and direct response. 0. What is the ratio of the Emissions (1000 metric ton of CO2 equivalent) in 2005 in Iceland to that in Indonesia?
Offer a very short reply. 0. What is the ratio of the Emissions (1000 metric ton of CO2 equivalent) of 2008 in Iceland to that in Indonesia?
Offer a very short reply. 0. What is the ratio of the Emissions (1000 metric ton of CO2 equivalent) in 1990 in Iceland to that in Iran?
Your answer should be very brief. 0.01. What is the ratio of the Emissions (1000 metric ton of CO2 equivalent) in 2000 in Iceland to that in Iran?
Provide a short and direct response. 0.01. What is the ratio of the Emissions (1000 metric ton of CO2 equivalent) in 2005 in Iceland to that in Iran?
Offer a terse response. 0.01. What is the ratio of the Emissions (1000 metric ton of CO2 equivalent) in 2008 in Iceland to that in Iran?
Offer a very short reply. 0.01. What is the ratio of the Emissions (1000 metric ton of CO2 equivalent) of 1990 in India to that in Indonesia?
Provide a succinct answer. 4.48. What is the ratio of the Emissions (1000 metric ton of CO2 equivalent) in 2000 in India to that in Indonesia?
Your response must be concise. 4.77. What is the ratio of the Emissions (1000 metric ton of CO2 equivalent) of 2005 in India to that in Indonesia?
Give a very brief answer. 3.82. What is the ratio of the Emissions (1000 metric ton of CO2 equivalent) of 2008 in India to that in Indonesia?
Your answer should be very brief. 4.28. What is the ratio of the Emissions (1000 metric ton of CO2 equivalent) in 1990 in India to that in Iran?
Offer a terse response. 20.78. What is the ratio of the Emissions (1000 metric ton of CO2 equivalent) in 2000 in India to that in Iran?
Ensure brevity in your answer.  18.98. What is the ratio of the Emissions (1000 metric ton of CO2 equivalent) of 2005 in India to that in Iran?
Provide a short and direct response. 18. What is the ratio of the Emissions (1000 metric ton of CO2 equivalent) in 2008 in India to that in Iran?
Your answer should be very brief. 18.29. What is the ratio of the Emissions (1000 metric ton of CO2 equivalent) of 1990 in Indonesia to that in Iran?
Your response must be concise. 4.64. What is the ratio of the Emissions (1000 metric ton of CO2 equivalent) of 2000 in Indonesia to that in Iran?
Offer a terse response. 3.98. What is the ratio of the Emissions (1000 metric ton of CO2 equivalent) of 2005 in Indonesia to that in Iran?
Give a very brief answer. 4.71. What is the ratio of the Emissions (1000 metric ton of CO2 equivalent) in 2008 in Indonesia to that in Iran?
Offer a very short reply. 4.27. What is the difference between the highest and the second highest Emissions (1000 metric ton of CO2 equivalent) of 1990?
Offer a terse response. 2.85e+05. What is the difference between the highest and the second highest Emissions (1000 metric ton of CO2 equivalent) of 2000?
Provide a short and direct response. 2.97e+05. What is the difference between the highest and the second highest Emissions (1000 metric ton of CO2 equivalent) of 2005?
Your response must be concise. 2.78e+05. What is the difference between the highest and the second highest Emissions (1000 metric ton of CO2 equivalent) of 2008?
Ensure brevity in your answer.  2.91e+05. What is the difference between the highest and the lowest Emissions (1000 metric ton of CO2 equivalent) in 1990?
Your response must be concise. 3.67e+05. What is the difference between the highest and the lowest Emissions (1000 metric ton of CO2 equivalent) in 2000?
Offer a very short reply. 3.76e+05. What is the difference between the highest and the lowest Emissions (1000 metric ton of CO2 equivalent) of 2005?
Your answer should be compact. 3.76e+05. What is the difference between the highest and the lowest Emissions (1000 metric ton of CO2 equivalent) in 2008?
Give a very brief answer. 3.80e+05. 